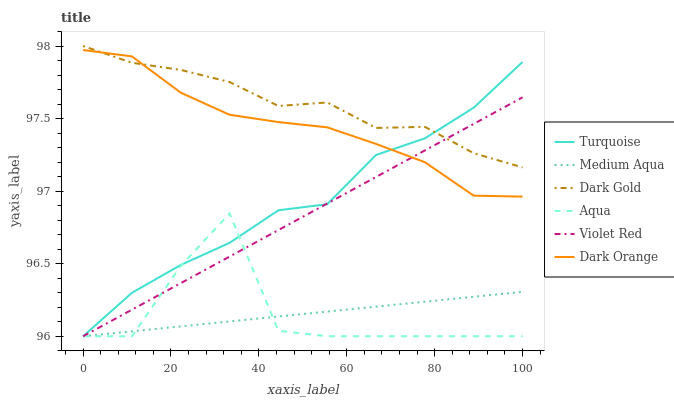Does Aqua have the minimum area under the curve?
Answer yes or no. Yes. Does Dark Gold have the maximum area under the curve?
Answer yes or no. Yes. Does Turquoise have the minimum area under the curve?
Answer yes or no. No. Does Turquoise have the maximum area under the curve?
Answer yes or no. No. Is Violet Red the smoothest?
Answer yes or no. Yes. Is Aqua the roughest?
Answer yes or no. Yes. Is Turquoise the smoothest?
Answer yes or no. No. Is Turquoise the roughest?
Answer yes or no. No. Does Turquoise have the lowest value?
Answer yes or no. Yes. Does Dark Gold have the lowest value?
Answer yes or no. No. Does Dark Gold have the highest value?
Answer yes or no. Yes. Does Turquoise have the highest value?
Answer yes or no. No. Is Medium Aqua less than Dark Gold?
Answer yes or no. Yes. Is Dark Orange greater than Aqua?
Answer yes or no. Yes. Does Turquoise intersect Dark Gold?
Answer yes or no. Yes. Is Turquoise less than Dark Gold?
Answer yes or no. No. Is Turquoise greater than Dark Gold?
Answer yes or no. No. Does Medium Aqua intersect Dark Gold?
Answer yes or no. No. 